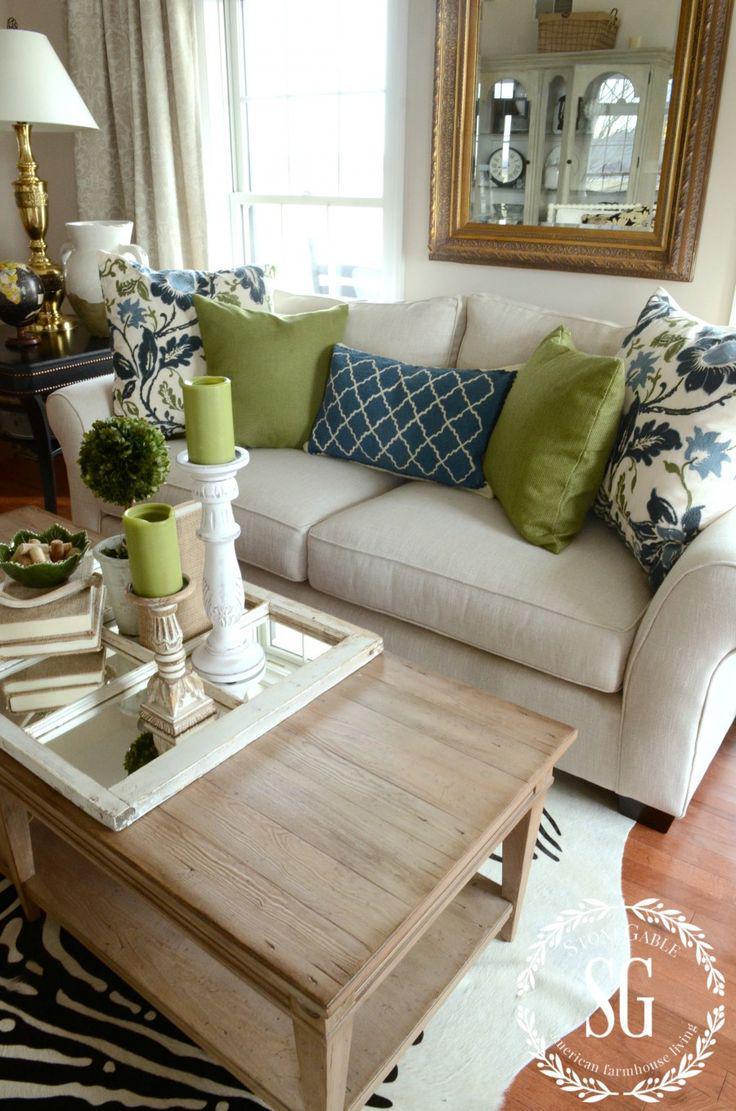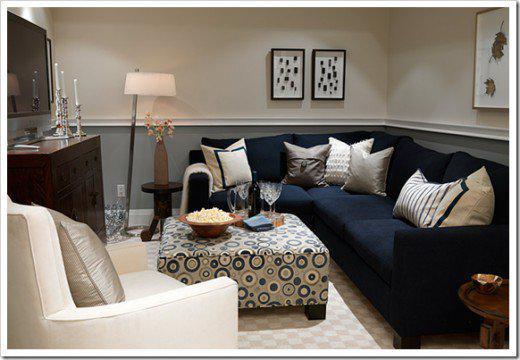The first image is the image on the left, the second image is the image on the right. Examine the images to the left and right. Is the description "There is a blue couch on the right image" accurate? Answer yes or no. Yes. The first image is the image on the left, the second image is the image on the right. For the images displayed, is the sentence "There is a couch with rolled arms and at least one of its pillows has a bold, geometric black and white design." factually correct? Answer yes or no. No. 